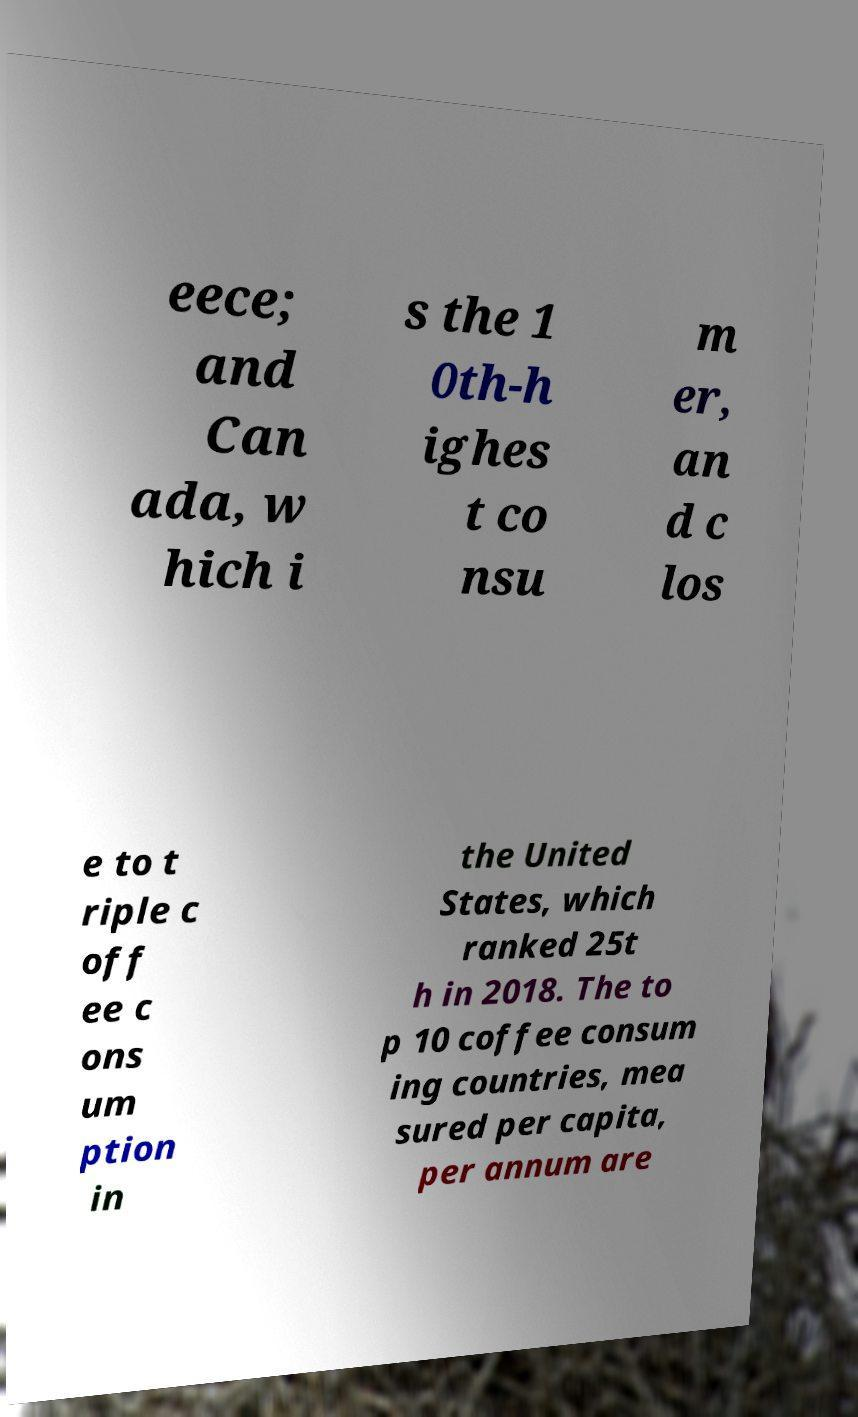Please read and relay the text visible in this image. What does it say? eece; and Can ada, w hich i s the 1 0th-h ighes t co nsu m er, an d c los e to t riple c off ee c ons um ption in the United States, which ranked 25t h in 2018. The to p 10 coffee consum ing countries, mea sured per capita, per annum are 